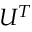<formula> <loc_0><loc_0><loc_500><loc_500>U ^ { T }</formula> 